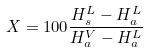<formula> <loc_0><loc_0><loc_500><loc_500>X = 1 0 0 \frac { H _ { s } ^ { L } - H _ { a } ^ { L } } { H _ { a } ^ { V } - H _ { a } ^ { L } }</formula> 